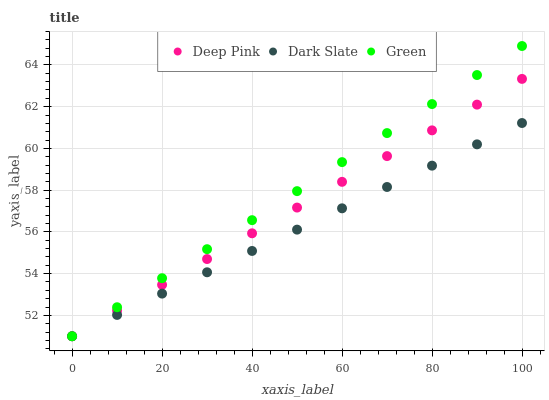Does Dark Slate have the minimum area under the curve?
Answer yes or no. Yes. Does Green have the maximum area under the curve?
Answer yes or no. Yes. Does Deep Pink have the minimum area under the curve?
Answer yes or no. No. Does Deep Pink have the maximum area under the curve?
Answer yes or no. No. Is Dark Slate the smoothest?
Answer yes or no. Yes. Is Deep Pink the roughest?
Answer yes or no. Yes. Is Deep Pink the smoothest?
Answer yes or no. No. Is Green the roughest?
Answer yes or no. No. Does Dark Slate have the lowest value?
Answer yes or no. Yes. Does Green have the highest value?
Answer yes or no. Yes. Does Deep Pink have the highest value?
Answer yes or no. No. Does Green intersect Deep Pink?
Answer yes or no. Yes. Is Green less than Deep Pink?
Answer yes or no. No. Is Green greater than Deep Pink?
Answer yes or no. No. 